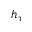Convert formula to latex. <formula><loc_0><loc_0><loc_500><loc_500>h _ { \tau }</formula> 